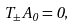Convert formula to latex. <formula><loc_0><loc_0><loc_500><loc_500>T _ { \pm } A _ { 0 } = 0 ,</formula> 